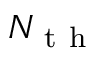Convert formula to latex. <formula><loc_0><loc_0><loc_500><loc_500>N _ { t h }</formula> 